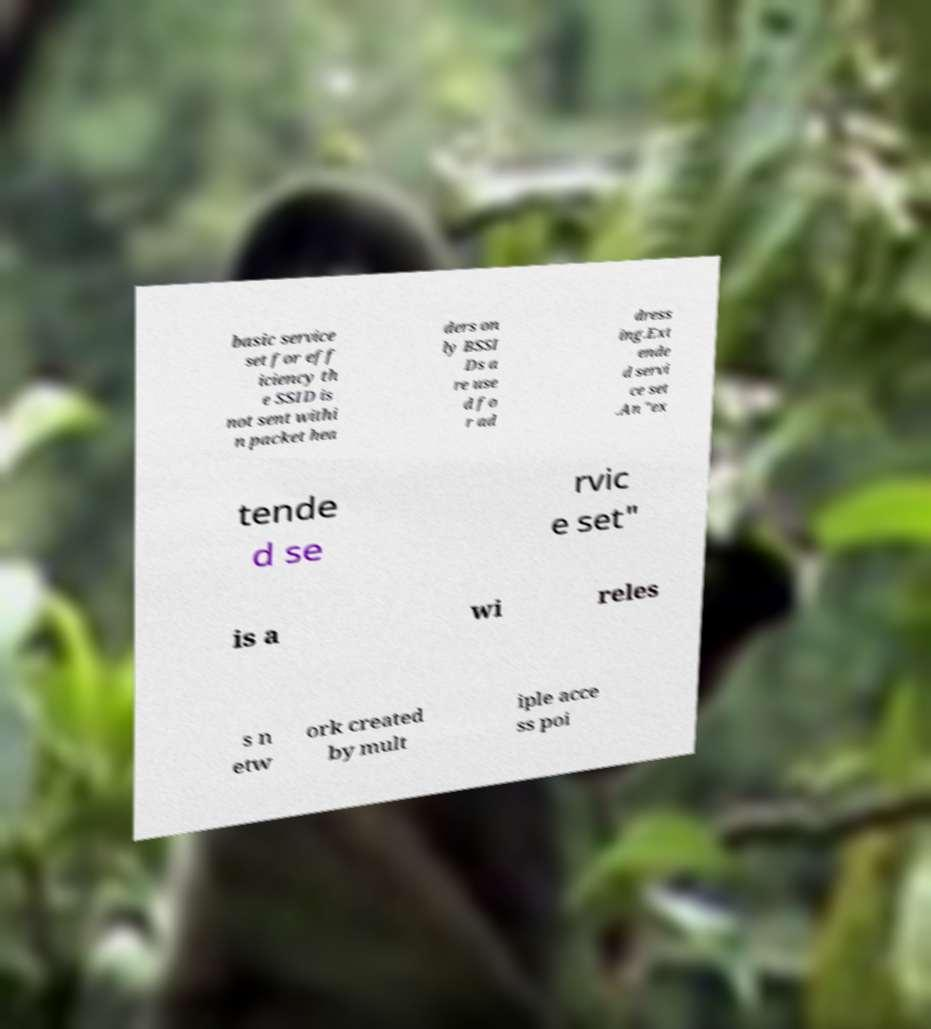Can you read and provide the text displayed in the image?This photo seems to have some interesting text. Can you extract and type it out for me? basic service set for eff iciency th e SSID is not sent withi n packet hea ders on ly BSSI Ds a re use d fo r ad dress ing.Ext ende d servi ce set .An "ex tende d se rvic e set" is a wi reles s n etw ork created by mult iple acce ss poi 